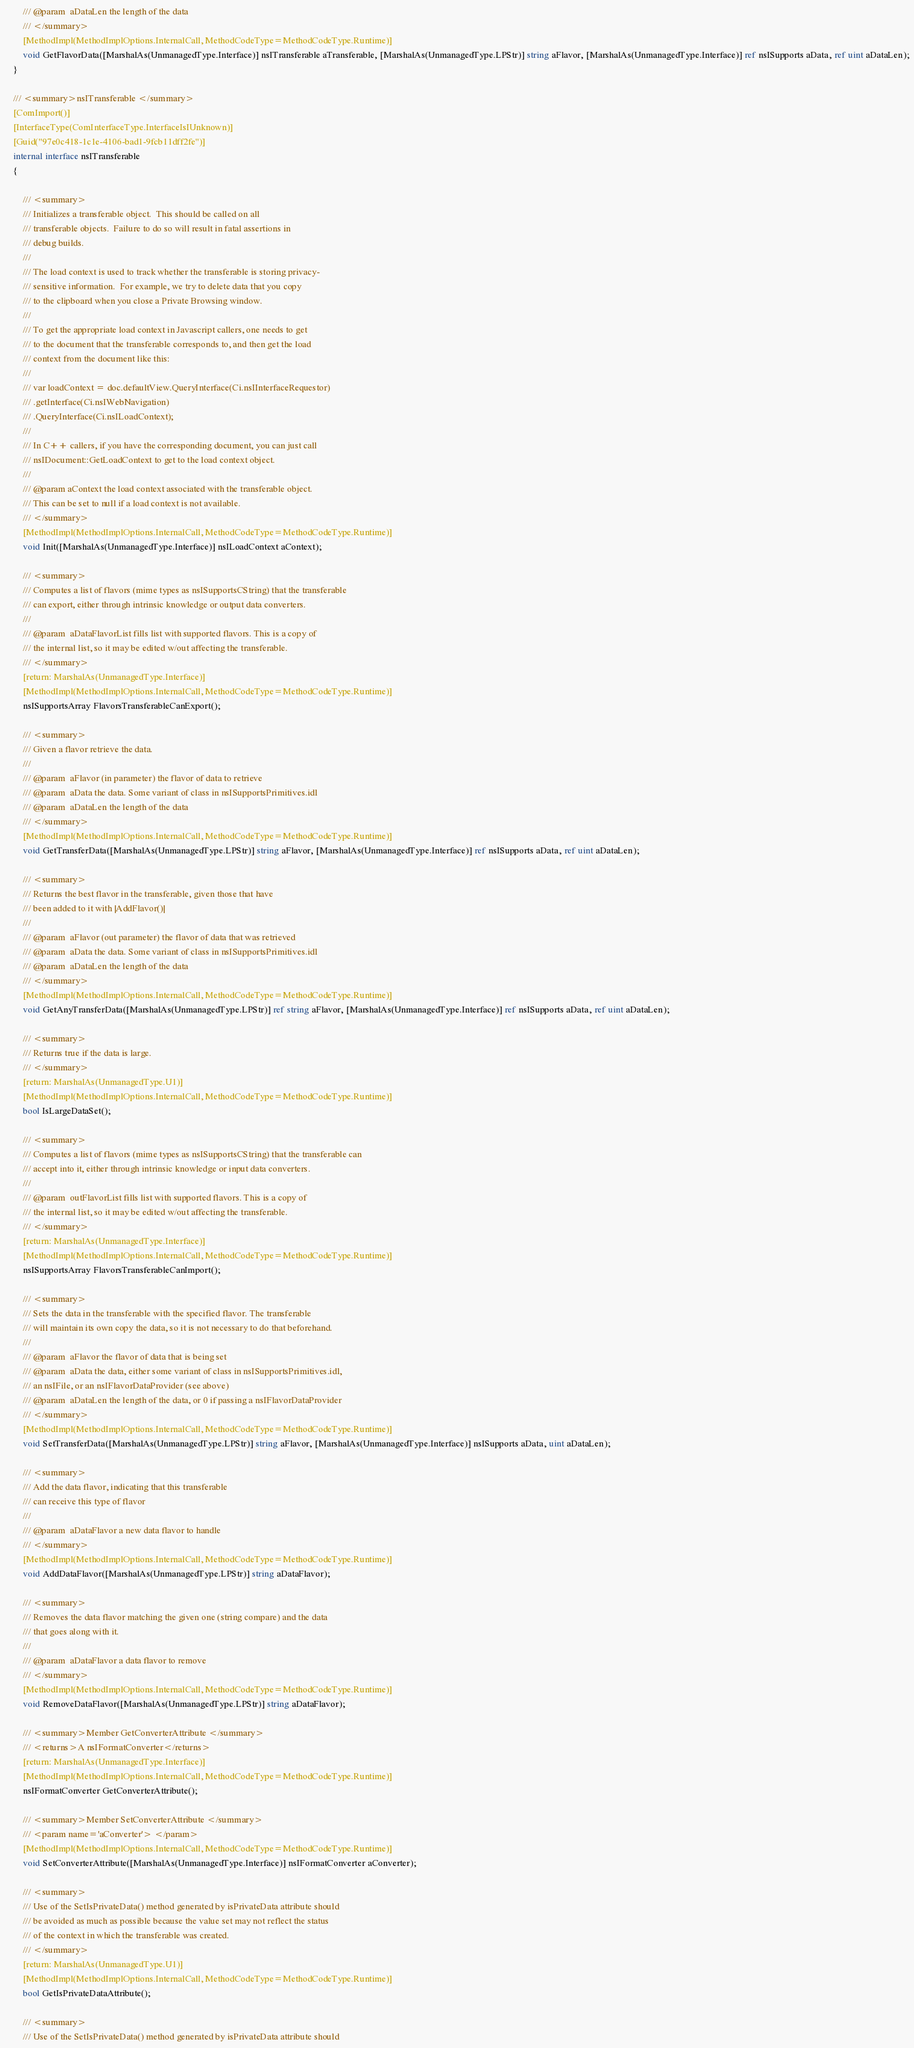Convert code to text. <code><loc_0><loc_0><loc_500><loc_500><_C#_>        /// @param  aDataLen the length of the data
        /// </summary>
		[MethodImpl(MethodImplOptions.InternalCall, MethodCodeType=MethodCodeType.Runtime)]
		void GetFlavorData([MarshalAs(UnmanagedType.Interface)] nsITransferable aTransferable, [MarshalAs(UnmanagedType.LPStr)] string aFlavor, [MarshalAs(UnmanagedType.Interface)] ref nsISupports aData, ref uint aDataLen);
	}
	
	/// <summary>nsITransferable </summary>
	[ComImport()]
	[InterfaceType(ComInterfaceType.InterfaceIsIUnknown)]
	[Guid("97e0c418-1c1e-4106-bad1-9fcb11dff2fe")]
	internal interface nsITransferable
	{
		
		/// <summary>
        /// Initializes a transferable object.  This should be called on all
        /// transferable objects.  Failure to do so will result in fatal assertions in
        /// debug builds.
        ///
        /// The load context is used to track whether the transferable is storing privacy-
        /// sensitive information.  For example, we try to delete data that you copy
        /// to the clipboard when you close a Private Browsing window.
        ///
        /// To get the appropriate load context in Javascript callers, one needs to get
        /// to the document that the transferable corresponds to, and then get the load
        /// context from the document like this:
        ///
        /// var loadContext = doc.defaultView.QueryInterface(Ci.nsIInterfaceRequestor)
        /// .getInterface(Ci.nsIWebNavigation)
        /// .QueryInterface(Ci.nsILoadContext);
        ///
        /// In C++ callers, if you have the corresponding document, you can just call
        /// nsIDocument::GetLoadContext to get to the load context object.
        ///
        /// @param aContext the load context associated with the transferable object.
        /// This can be set to null if a load context is not available.
        /// </summary>
		[MethodImpl(MethodImplOptions.InternalCall, MethodCodeType=MethodCodeType.Runtime)]
		void Init([MarshalAs(UnmanagedType.Interface)] nsILoadContext aContext);
		
		/// <summary>
        /// Computes a list of flavors (mime types as nsISupportsCString) that the transferable
        /// can export, either through intrinsic knowledge or output data converters.
        ///
        /// @param  aDataFlavorList fills list with supported flavors. This is a copy of
        /// the internal list, so it may be edited w/out affecting the transferable.
        /// </summary>
		[return: MarshalAs(UnmanagedType.Interface)]
		[MethodImpl(MethodImplOptions.InternalCall, MethodCodeType=MethodCodeType.Runtime)]
		nsISupportsArray FlavorsTransferableCanExport();
		
		/// <summary>
        /// Given a flavor retrieve the data.
        ///
        /// @param  aFlavor (in parameter) the flavor of data to retrieve
        /// @param  aData the data. Some variant of class in nsISupportsPrimitives.idl
        /// @param  aDataLen the length of the data
        /// </summary>
		[MethodImpl(MethodImplOptions.InternalCall, MethodCodeType=MethodCodeType.Runtime)]
		void GetTransferData([MarshalAs(UnmanagedType.LPStr)] string aFlavor, [MarshalAs(UnmanagedType.Interface)] ref nsISupports aData, ref uint aDataLen);
		
		/// <summary>
        /// Returns the best flavor in the transferable, given those that have
        /// been added to it with |AddFlavor()|
        ///
        /// @param  aFlavor (out parameter) the flavor of data that was retrieved
        /// @param  aData the data. Some variant of class in nsISupportsPrimitives.idl
        /// @param  aDataLen the length of the data
        /// </summary>
		[MethodImpl(MethodImplOptions.InternalCall, MethodCodeType=MethodCodeType.Runtime)]
		void GetAnyTransferData([MarshalAs(UnmanagedType.LPStr)] ref string aFlavor, [MarshalAs(UnmanagedType.Interface)] ref nsISupports aData, ref uint aDataLen);
		
		/// <summary>
        /// Returns true if the data is large.
        /// </summary>
		[return: MarshalAs(UnmanagedType.U1)]
		[MethodImpl(MethodImplOptions.InternalCall, MethodCodeType=MethodCodeType.Runtime)]
		bool IsLargeDataSet();
		
		/// <summary>
        /// Computes a list of flavors (mime types as nsISupportsCString) that the transferable can
        /// accept into it, either through intrinsic knowledge or input data converters.
        ///
        /// @param  outFlavorList fills list with supported flavors. This is a copy of
        /// the internal list, so it may be edited w/out affecting the transferable.
        /// </summary>
		[return: MarshalAs(UnmanagedType.Interface)]
		[MethodImpl(MethodImplOptions.InternalCall, MethodCodeType=MethodCodeType.Runtime)]
		nsISupportsArray FlavorsTransferableCanImport();
		
		/// <summary>
        /// Sets the data in the transferable with the specified flavor. The transferable
        /// will maintain its own copy the data, so it is not necessary to do that beforehand.
        ///
        /// @param  aFlavor the flavor of data that is being set
        /// @param  aData the data, either some variant of class in nsISupportsPrimitives.idl,
        /// an nsIFile, or an nsIFlavorDataProvider (see above)
        /// @param  aDataLen the length of the data, or 0 if passing a nsIFlavorDataProvider
        /// </summary>
		[MethodImpl(MethodImplOptions.InternalCall, MethodCodeType=MethodCodeType.Runtime)]
		void SetTransferData([MarshalAs(UnmanagedType.LPStr)] string aFlavor, [MarshalAs(UnmanagedType.Interface)] nsISupports aData, uint aDataLen);
		
		/// <summary>
        /// Add the data flavor, indicating that this transferable
        /// can receive this type of flavor
        ///
        /// @param  aDataFlavor a new data flavor to handle
        /// </summary>
		[MethodImpl(MethodImplOptions.InternalCall, MethodCodeType=MethodCodeType.Runtime)]
		void AddDataFlavor([MarshalAs(UnmanagedType.LPStr)] string aDataFlavor);
		
		/// <summary>
        /// Removes the data flavor matching the given one (string compare) and the data
        /// that goes along with it.
        ///
        /// @param  aDataFlavor a data flavor to remove
        /// </summary>
		[MethodImpl(MethodImplOptions.InternalCall, MethodCodeType=MethodCodeType.Runtime)]
		void RemoveDataFlavor([MarshalAs(UnmanagedType.LPStr)] string aDataFlavor);
		
		/// <summary>Member GetConverterAttribute </summary>
		/// <returns>A nsIFormatConverter</returns>
		[return: MarshalAs(UnmanagedType.Interface)]
		[MethodImpl(MethodImplOptions.InternalCall, MethodCodeType=MethodCodeType.Runtime)]
		nsIFormatConverter GetConverterAttribute();
		
		/// <summary>Member SetConverterAttribute </summary>
		/// <param name='aConverter'> </param>
		[MethodImpl(MethodImplOptions.InternalCall, MethodCodeType=MethodCodeType.Runtime)]
		void SetConverterAttribute([MarshalAs(UnmanagedType.Interface)] nsIFormatConverter aConverter);
		
		/// <summary>
        /// Use of the SetIsPrivateData() method generated by isPrivateData attribute should
        /// be avoided as much as possible because the value set may not reflect the status
        /// of the context in which the transferable was created.
        /// </summary>
		[return: MarshalAs(UnmanagedType.U1)]
		[MethodImpl(MethodImplOptions.InternalCall, MethodCodeType=MethodCodeType.Runtime)]
		bool GetIsPrivateDataAttribute();
		
		/// <summary>
        /// Use of the SetIsPrivateData() method generated by isPrivateData attribute should</code> 